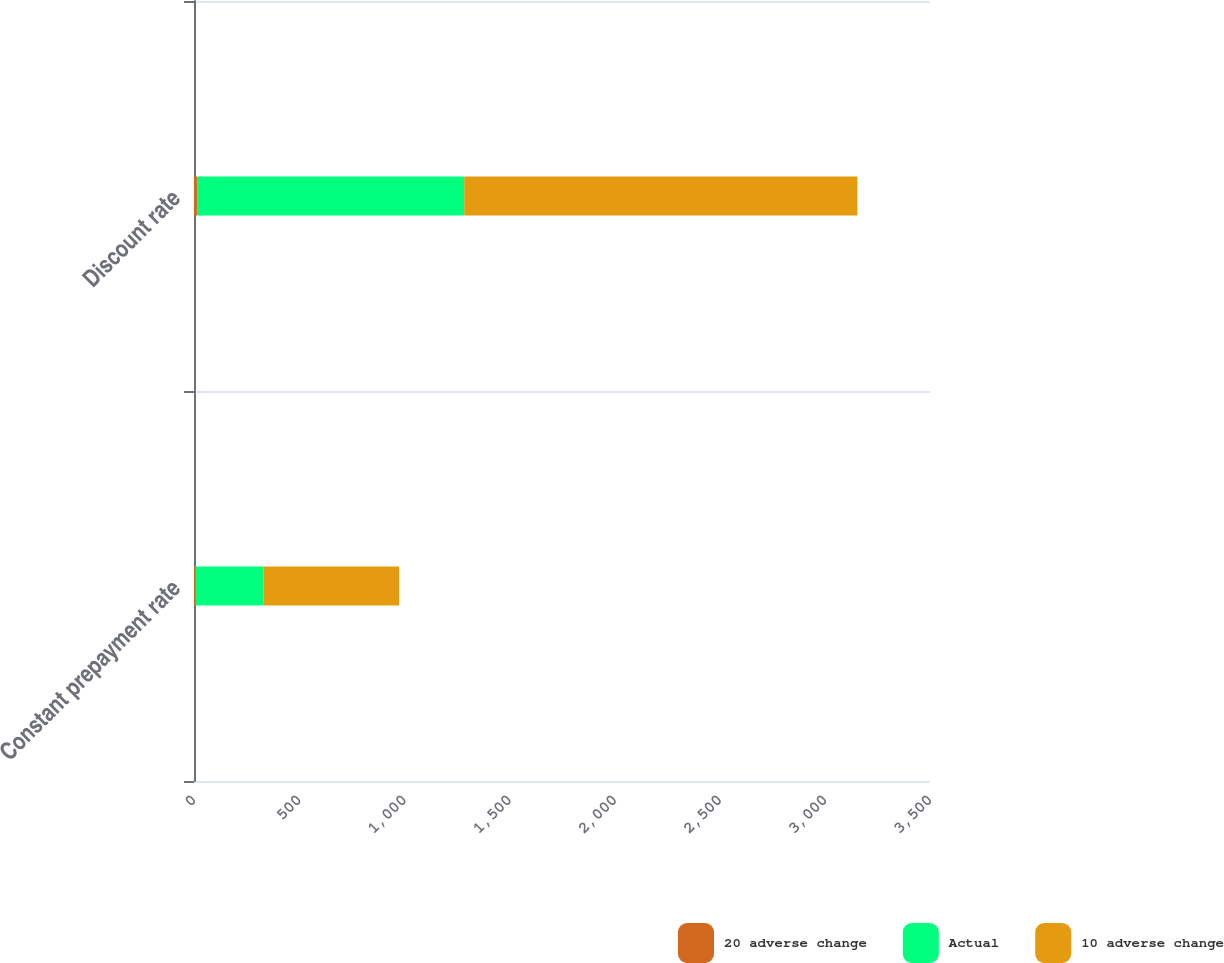<chart> <loc_0><loc_0><loc_500><loc_500><stacked_bar_chart><ecel><fcel>Constant prepayment rate<fcel>Discount rate<nl><fcel>20 adverse change<fcel>7.4<fcel>15<nl><fcel>Actual<fcel>324<fcel>1270<nl><fcel>10 adverse change<fcel>644<fcel>1870<nl></chart> 